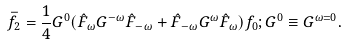<formula> <loc_0><loc_0><loc_500><loc_500>\bar { f } _ { 2 } = \frac { 1 } { 4 } G ^ { 0 } ( \hat { F } _ { \omega } G ^ { - \omega } \hat { F } _ { - \omega } + \hat { F } _ { - \omega } G ^ { \omega } \hat { F } _ { \omega } ) f _ { 0 } ; G ^ { 0 } \equiv G ^ { \omega = 0 } .</formula> 